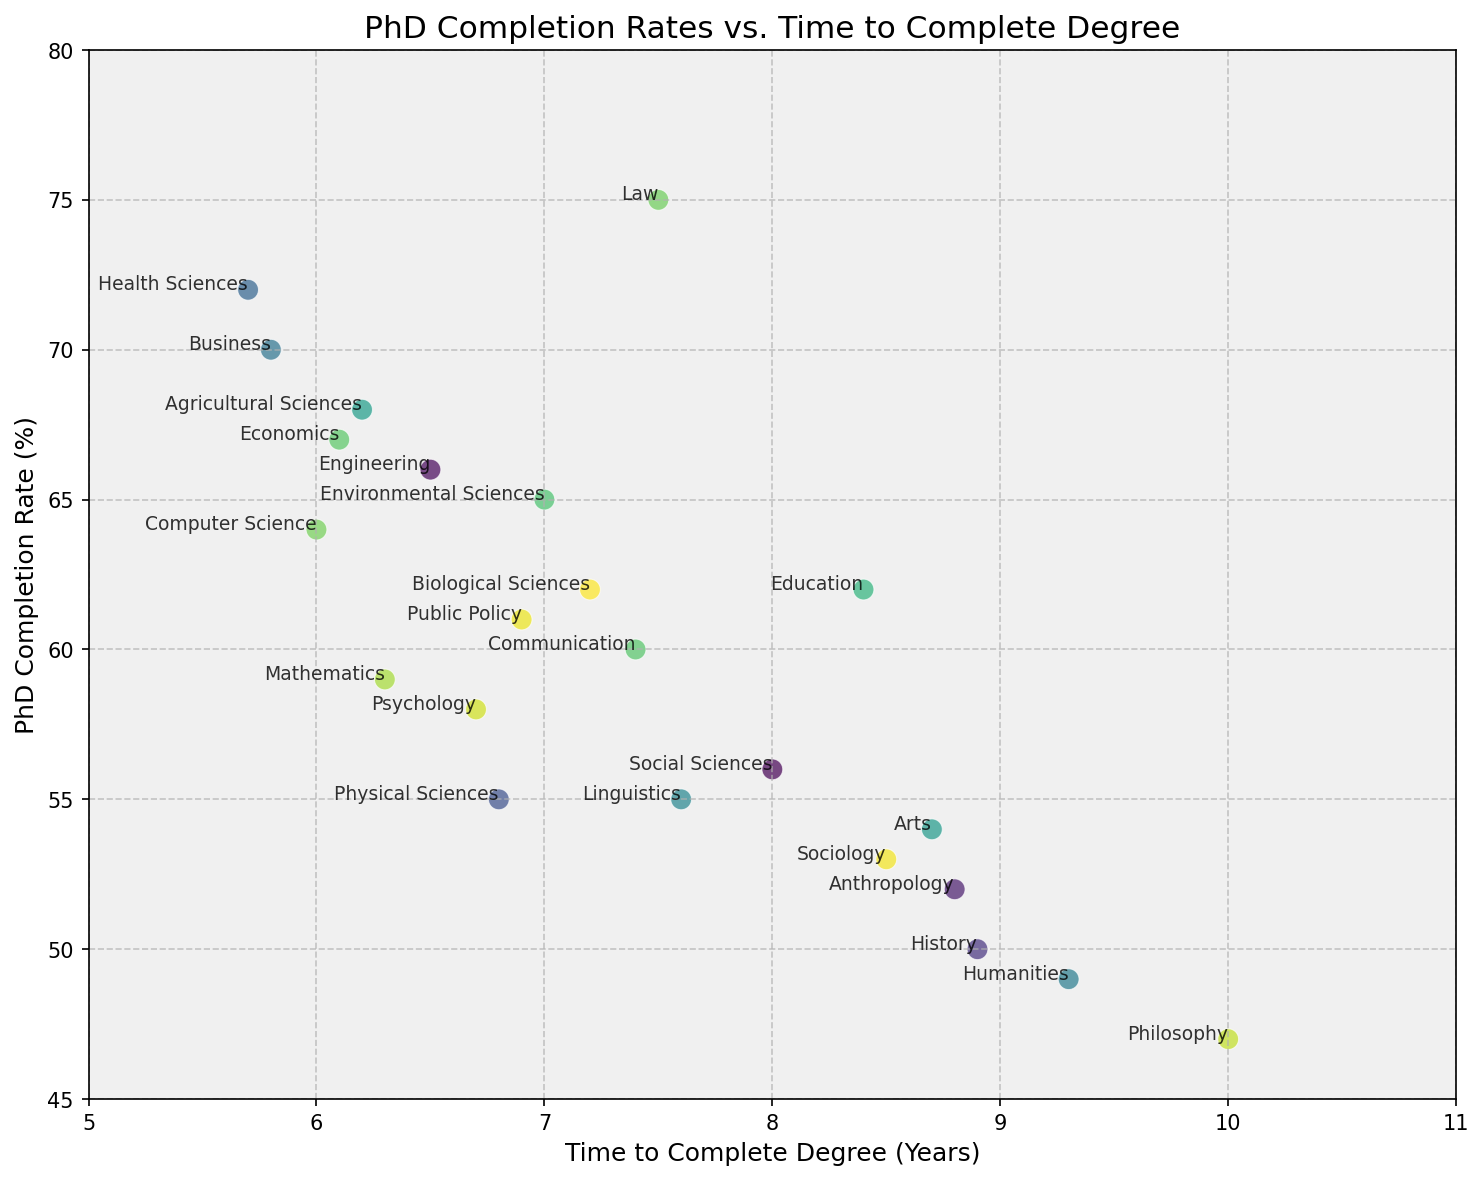What's the discipline with the highest PhD completion rate? By observing the scatter plot, identify the point that has the highest vertical position indicating the PhD completion rate.
Answer: Law What is the average time to complete a PhD degree for Computer Science, Mathematics, and Economics? Find the time to complete degrees for Computer Science (6.0 years), Mathematics (6.3 years), and Economics (6.1 years). Calculate the average: (6.0 + 6.3 + 6.1) / 3 = 6.13 years.
Answer: 6.13 years How does the completion rate of Business compare to Education? Find the vertical positions for both Business (70%) and Education (62%) and compare them. Business has a higher completion rate.
Answer: Business has a higher completion rate Which discipline takes the longest time to complete a PhD degree, and what is the time? Identify the point that is farthest to the right on the horizontal axis. The discipline is Philosophy with a time to complete of 10.0 years.
Answer: Philosophy, 10.0 years What is the difference in PhD completion rates between Engineering and Humanities? Engineering has a completion rate of 66%, and Humanities has a completion rate of 49%. The difference is 66% - 49% = 17%.
Answer: 17% Which discipline has a higher completion rate, Sociology or Psychology? Compare their vertical positions: Sociology (53%), Psychology (58%). Psychology has a higher completion rate.
Answer: Psychology What is the combined completion rate for Environmental Sciences, Law, and Arts? Sum the completion rates: Environmental Sciences (65%), Law (75%), and Arts (54%). The combined rate is 65% + 75% + 54% = 194%.
Answer: 194% How many disciplines have a completion rate greater than 60%? Count the points above the 60% mark: Biological Sciences, Engineering, Education, Business, Computer Science, Health Sciences, Agricultural Sciences, Environmental Sciences, Law, Public Policy, and Communication, which are 11 disciplines.
Answer: 11 What is the median time to complete a PhD degree across all disciplines? List all times to complete and find the median value: 5.7, 5.8, 6.0, 6.1, 6.2, 6.3, 6.5, 6.7, 6.8, 6.9, 7.0, 7.2, 7.4, 7.5, 7.6, 8.0, 8.4, 8.5, 8.7, 8.8, 8.9, 9.3, 10. The median value (middle value in the ordered list) is 7.0 years.
Answer: 7.0 years 